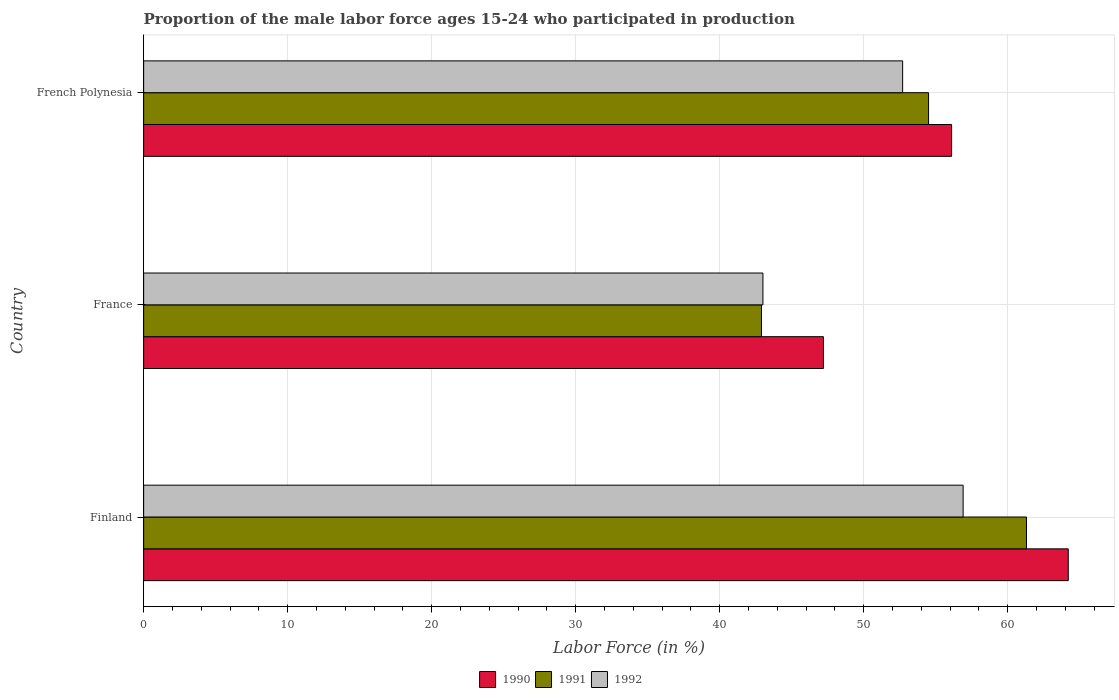Are the number of bars on each tick of the Y-axis equal?
Your answer should be compact. Yes. How many bars are there on the 3rd tick from the top?
Your answer should be very brief. 3. How many bars are there on the 2nd tick from the bottom?
Give a very brief answer. 3. What is the label of the 3rd group of bars from the top?
Offer a terse response. Finland. In how many cases, is the number of bars for a given country not equal to the number of legend labels?
Give a very brief answer. 0. What is the proportion of the male labor force who participated in production in 1991 in French Polynesia?
Offer a terse response. 54.5. Across all countries, what is the maximum proportion of the male labor force who participated in production in 1990?
Your response must be concise. 64.2. Across all countries, what is the minimum proportion of the male labor force who participated in production in 1990?
Offer a terse response. 47.2. What is the total proportion of the male labor force who participated in production in 1991 in the graph?
Offer a very short reply. 158.7. What is the difference between the proportion of the male labor force who participated in production in 1991 in Finland and that in French Polynesia?
Offer a terse response. 6.8. What is the difference between the proportion of the male labor force who participated in production in 1991 in France and the proportion of the male labor force who participated in production in 1990 in Finland?
Make the answer very short. -21.3. What is the average proportion of the male labor force who participated in production in 1992 per country?
Offer a very short reply. 50.87. What is the difference between the proportion of the male labor force who participated in production in 1991 and proportion of the male labor force who participated in production in 1990 in Finland?
Keep it short and to the point. -2.9. What is the ratio of the proportion of the male labor force who participated in production in 1992 in Finland to that in French Polynesia?
Make the answer very short. 1.08. What is the difference between the highest and the second highest proportion of the male labor force who participated in production in 1992?
Provide a short and direct response. 4.2. What is the difference between the highest and the lowest proportion of the male labor force who participated in production in 1992?
Provide a succinct answer. 13.9. Is the sum of the proportion of the male labor force who participated in production in 1990 in Finland and France greater than the maximum proportion of the male labor force who participated in production in 1992 across all countries?
Give a very brief answer. Yes. Are the values on the major ticks of X-axis written in scientific E-notation?
Provide a succinct answer. No. Does the graph contain grids?
Offer a very short reply. Yes. Where does the legend appear in the graph?
Provide a succinct answer. Bottom center. How many legend labels are there?
Your answer should be very brief. 3. What is the title of the graph?
Your response must be concise. Proportion of the male labor force ages 15-24 who participated in production. What is the Labor Force (in %) in 1990 in Finland?
Your answer should be very brief. 64.2. What is the Labor Force (in %) of 1991 in Finland?
Offer a very short reply. 61.3. What is the Labor Force (in %) in 1992 in Finland?
Offer a very short reply. 56.9. What is the Labor Force (in %) of 1990 in France?
Provide a succinct answer. 47.2. What is the Labor Force (in %) in 1991 in France?
Keep it short and to the point. 42.9. What is the Labor Force (in %) of 1990 in French Polynesia?
Make the answer very short. 56.1. What is the Labor Force (in %) in 1991 in French Polynesia?
Keep it short and to the point. 54.5. What is the Labor Force (in %) in 1992 in French Polynesia?
Provide a succinct answer. 52.7. Across all countries, what is the maximum Labor Force (in %) in 1990?
Offer a very short reply. 64.2. Across all countries, what is the maximum Labor Force (in %) in 1991?
Offer a very short reply. 61.3. Across all countries, what is the maximum Labor Force (in %) of 1992?
Your answer should be very brief. 56.9. Across all countries, what is the minimum Labor Force (in %) in 1990?
Your answer should be compact. 47.2. Across all countries, what is the minimum Labor Force (in %) of 1991?
Offer a terse response. 42.9. What is the total Labor Force (in %) of 1990 in the graph?
Offer a terse response. 167.5. What is the total Labor Force (in %) in 1991 in the graph?
Your answer should be very brief. 158.7. What is the total Labor Force (in %) in 1992 in the graph?
Your response must be concise. 152.6. What is the difference between the Labor Force (in %) in 1991 in Finland and that in France?
Provide a short and direct response. 18.4. What is the difference between the Labor Force (in %) of 1992 in Finland and that in France?
Keep it short and to the point. 13.9. What is the difference between the Labor Force (in %) in 1990 in Finland and that in French Polynesia?
Ensure brevity in your answer.  8.1. What is the difference between the Labor Force (in %) in 1991 in Finland and that in French Polynesia?
Provide a succinct answer. 6.8. What is the difference between the Labor Force (in %) in 1992 in Finland and that in French Polynesia?
Your response must be concise. 4.2. What is the difference between the Labor Force (in %) of 1990 in Finland and the Labor Force (in %) of 1991 in France?
Give a very brief answer. 21.3. What is the difference between the Labor Force (in %) in 1990 in Finland and the Labor Force (in %) in 1992 in France?
Ensure brevity in your answer.  21.2. What is the difference between the Labor Force (in %) of 1991 in Finland and the Labor Force (in %) of 1992 in France?
Offer a very short reply. 18.3. What is the difference between the Labor Force (in %) of 1990 in Finland and the Labor Force (in %) of 1991 in French Polynesia?
Offer a terse response. 9.7. What is the difference between the Labor Force (in %) of 1990 in France and the Labor Force (in %) of 1992 in French Polynesia?
Provide a succinct answer. -5.5. What is the difference between the Labor Force (in %) of 1991 in France and the Labor Force (in %) of 1992 in French Polynesia?
Give a very brief answer. -9.8. What is the average Labor Force (in %) of 1990 per country?
Offer a terse response. 55.83. What is the average Labor Force (in %) in 1991 per country?
Provide a short and direct response. 52.9. What is the average Labor Force (in %) of 1992 per country?
Ensure brevity in your answer.  50.87. What is the difference between the Labor Force (in %) in 1990 and Labor Force (in %) in 1991 in Finland?
Provide a short and direct response. 2.9. What is the difference between the Labor Force (in %) of 1990 and Labor Force (in %) of 1992 in France?
Keep it short and to the point. 4.2. What is the difference between the Labor Force (in %) of 1991 and Labor Force (in %) of 1992 in France?
Ensure brevity in your answer.  -0.1. What is the difference between the Labor Force (in %) of 1990 and Labor Force (in %) of 1992 in French Polynesia?
Provide a succinct answer. 3.4. What is the ratio of the Labor Force (in %) in 1990 in Finland to that in France?
Your answer should be compact. 1.36. What is the ratio of the Labor Force (in %) of 1991 in Finland to that in France?
Your answer should be compact. 1.43. What is the ratio of the Labor Force (in %) of 1992 in Finland to that in France?
Provide a succinct answer. 1.32. What is the ratio of the Labor Force (in %) of 1990 in Finland to that in French Polynesia?
Provide a short and direct response. 1.14. What is the ratio of the Labor Force (in %) in 1991 in Finland to that in French Polynesia?
Provide a short and direct response. 1.12. What is the ratio of the Labor Force (in %) in 1992 in Finland to that in French Polynesia?
Make the answer very short. 1.08. What is the ratio of the Labor Force (in %) of 1990 in France to that in French Polynesia?
Provide a succinct answer. 0.84. What is the ratio of the Labor Force (in %) in 1991 in France to that in French Polynesia?
Your response must be concise. 0.79. What is the ratio of the Labor Force (in %) of 1992 in France to that in French Polynesia?
Give a very brief answer. 0.82. What is the difference between the highest and the second highest Labor Force (in %) in 1991?
Your answer should be very brief. 6.8. What is the difference between the highest and the lowest Labor Force (in %) in 1990?
Provide a succinct answer. 17. What is the difference between the highest and the lowest Labor Force (in %) in 1991?
Give a very brief answer. 18.4. What is the difference between the highest and the lowest Labor Force (in %) in 1992?
Your answer should be very brief. 13.9. 